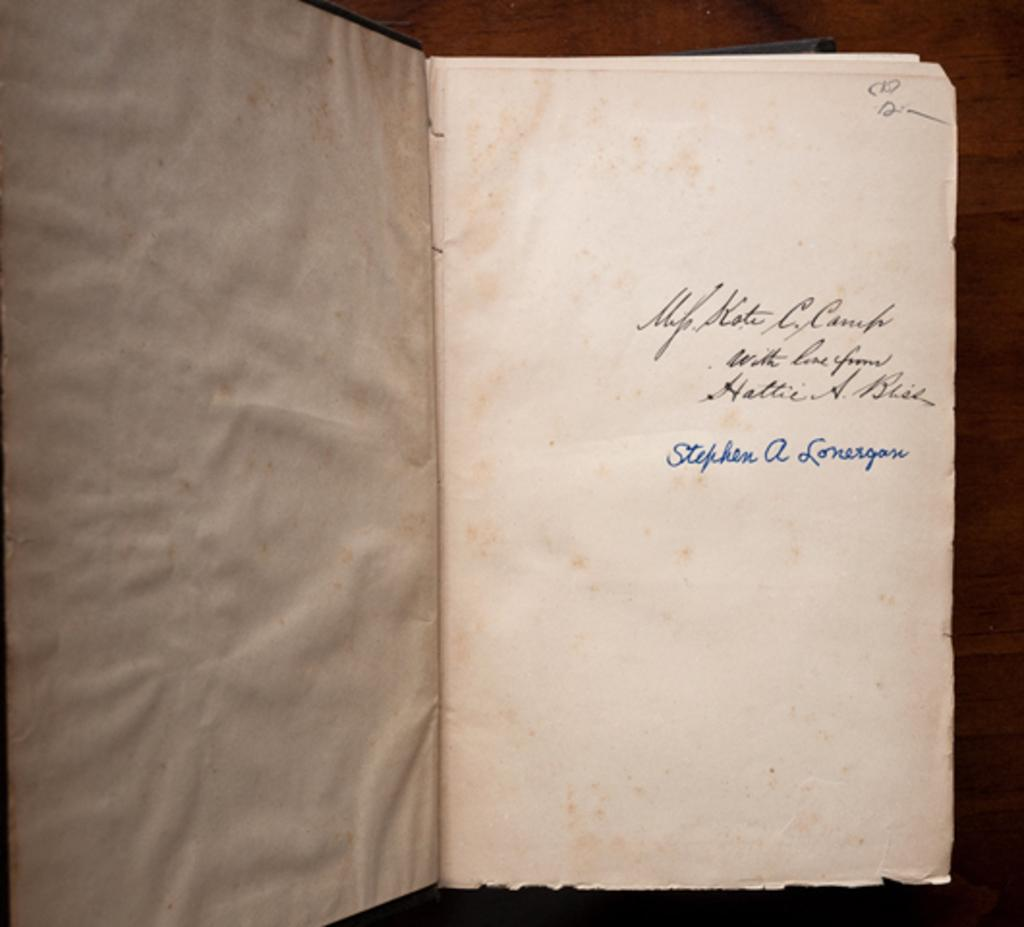<image>
Create a compact narrative representing the image presented. A book is opened to a page that is signed by someone named Stephen. 